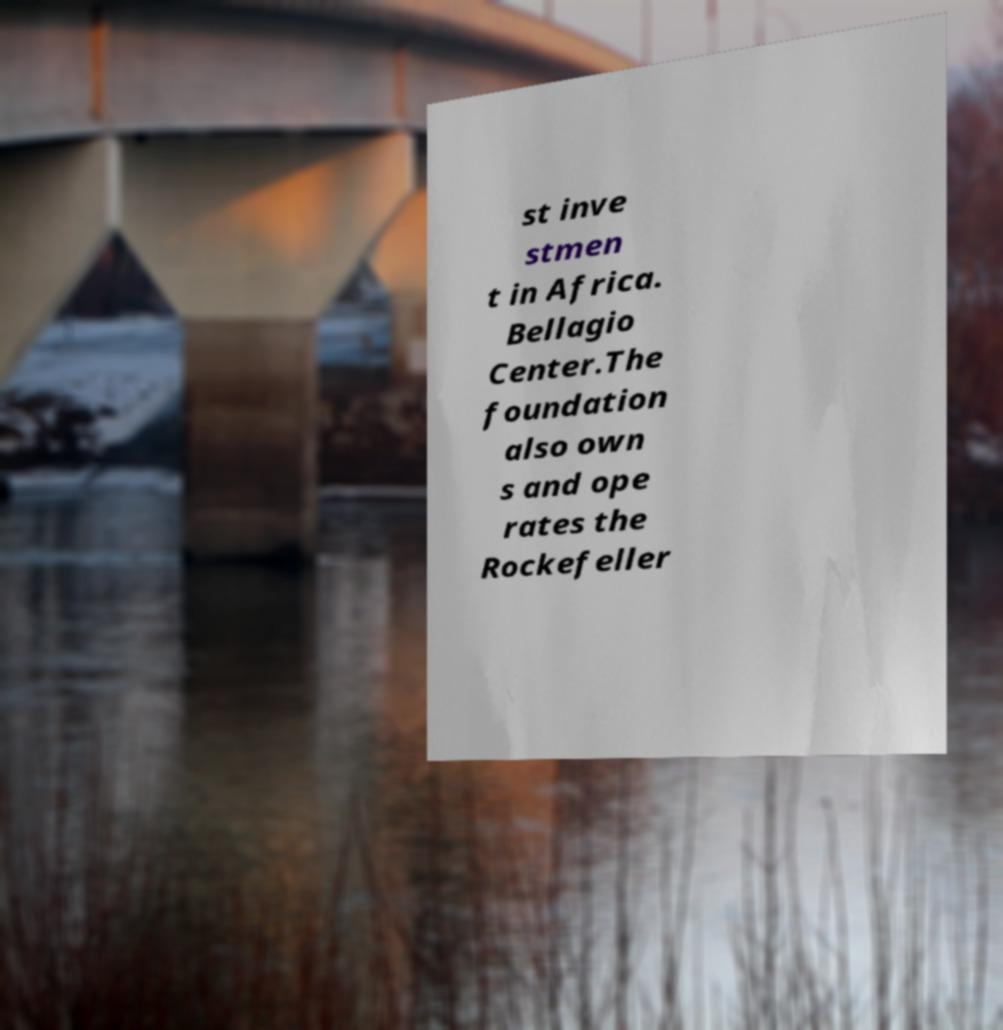Please identify and transcribe the text found in this image. st inve stmen t in Africa. Bellagio Center.The foundation also own s and ope rates the Rockefeller 